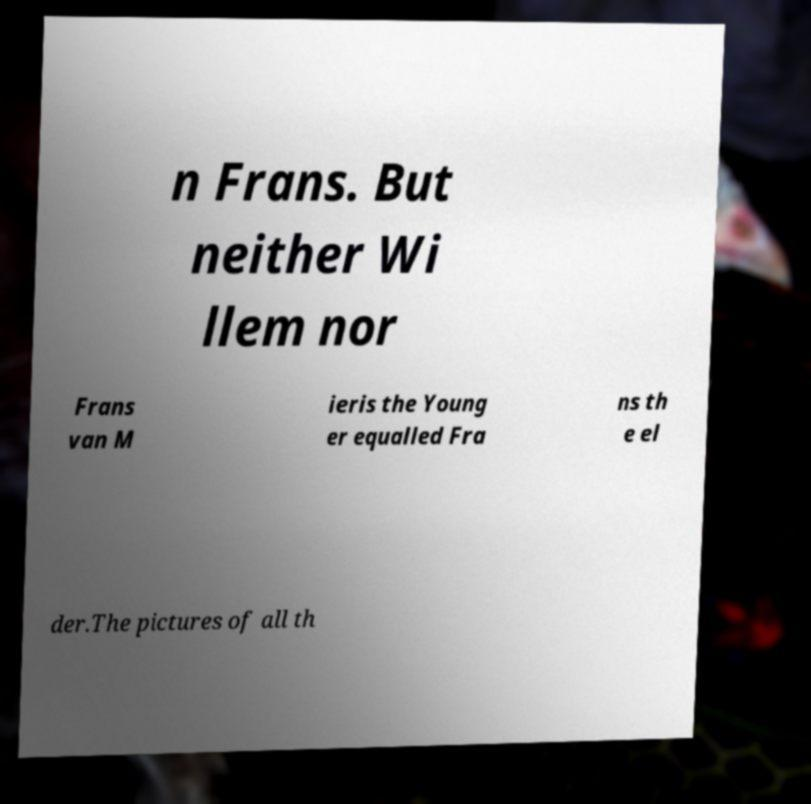Please read and relay the text visible in this image. What does it say? n Frans. But neither Wi llem nor Frans van M ieris the Young er equalled Fra ns th e el der.The pictures of all th 